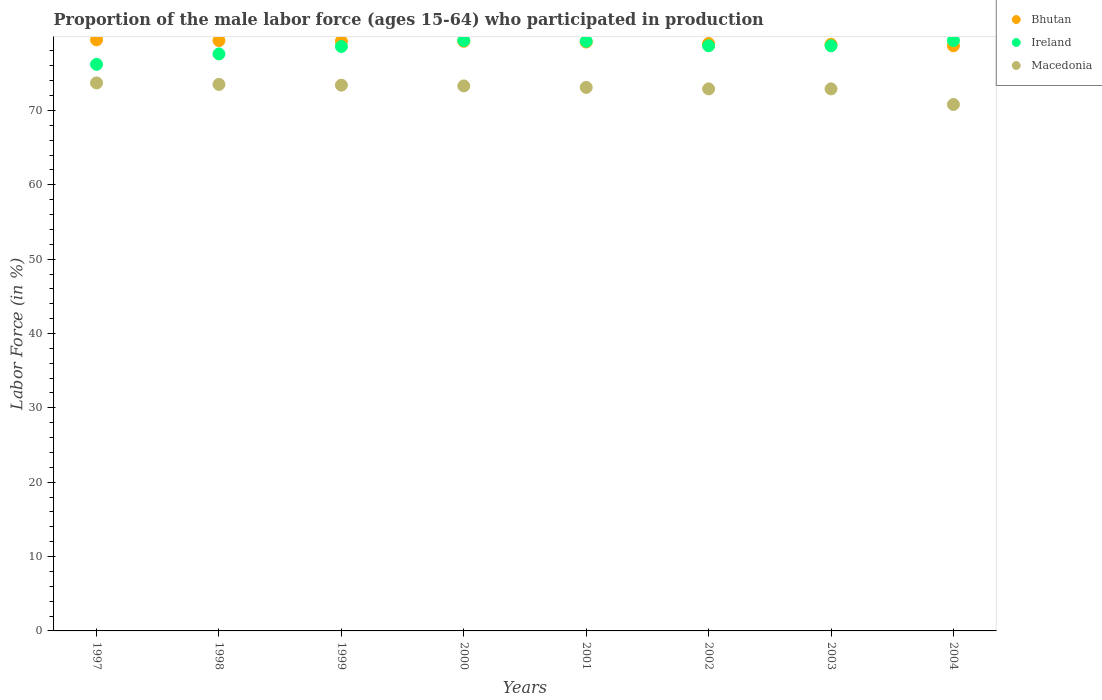How many different coloured dotlines are there?
Keep it short and to the point. 3. Is the number of dotlines equal to the number of legend labels?
Keep it short and to the point. Yes. What is the proportion of the male labor force who participated in production in Macedonia in 1999?
Give a very brief answer. 73.4. Across all years, what is the maximum proportion of the male labor force who participated in production in Ireland?
Ensure brevity in your answer.  79.4. Across all years, what is the minimum proportion of the male labor force who participated in production in Ireland?
Keep it short and to the point. 76.2. In which year was the proportion of the male labor force who participated in production in Bhutan maximum?
Your response must be concise. 1997. In which year was the proportion of the male labor force who participated in production in Bhutan minimum?
Your answer should be very brief. 2004. What is the total proportion of the male labor force who participated in production in Ireland in the graph?
Your answer should be very brief. 627.9. What is the difference between the proportion of the male labor force who participated in production in Macedonia in 1998 and that in 2001?
Your answer should be compact. 0.4. What is the difference between the proportion of the male labor force who participated in production in Macedonia in 2002 and the proportion of the male labor force who participated in production in Ireland in 1999?
Offer a terse response. -5.7. What is the average proportion of the male labor force who participated in production in Ireland per year?
Make the answer very short. 78.49. In the year 1997, what is the difference between the proportion of the male labor force who participated in production in Bhutan and proportion of the male labor force who participated in production in Macedonia?
Keep it short and to the point. 5.8. What is the ratio of the proportion of the male labor force who participated in production in Bhutan in 2000 to that in 2002?
Your response must be concise. 1. Is the proportion of the male labor force who participated in production in Ireland in 2001 less than that in 2003?
Your response must be concise. No. Is the difference between the proportion of the male labor force who participated in production in Bhutan in 1998 and 2000 greater than the difference between the proportion of the male labor force who participated in production in Macedonia in 1998 and 2000?
Provide a short and direct response. No. What is the difference between the highest and the second highest proportion of the male labor force who participated in production in Macedonia?
Provide a succinct answer. 0.2. What is the difference between the highest and the lowest proportion of the male labor force who participated in production in Ireland?
Your answer should be compact. 3.2. Is the sum of the proportion of the male labor force who participated in production in Bhutan in 1999 and 2004 greater than the maximum proportion of the male labor force who participated in production in Ireland across all years?
Offer a terse response. Yes. Is it the case that in every year, the sum of the proportion of the male labor force who participated in production in Macedonia and proportion of the male labor force who participated in production in Bhutan  is greater than the proportion of the male labor force who participated in production in Ireland?
Make the answer very short. Yes. Does the proportion of the male labor force who participated in production in Bhutan monotonically increase over the years?
Keep it short and to the point. No. Is the proportion of the male labor force who participated in production in Bhutan strictly greater than the proportion of the male labor force who participated in production in Ireland over the years?
Offer a very short reply. No. How many dotlines are there?
Provide a succinct answer. 3. How many years are there in the graph?
Make the answer very short. 8. What is the difference between two consecutive major ticks on the Y-axis?
Offer a terse response. 10. Does the graph contain grids?
Offer a terse response. No. Where does the legend appear in the graph?
Give a very brief answer. Top right. What is the title of the graph?
Make the answer very short. Proportion of the male labor force (ages 15-64) who participated in production. What is the Labor Force (in %) in Bhutan in 1997?
Your answer should be very brief. 79.5. What is the Labor Force (in %) of Ireland in 1997?
Your answer should be compact. 76.2. What is the Labor Force (in %) in Macedonia in 1997?
Keep it short and to the point. 73.7. What is the Labor Force (in %) of Bhutan in 1998?
Offer a terse response. 79.4. What is the Labor Force (in %) in Ireland in 1998?
Your response must be concise. 77.6. What is the Labor Force (in %) of Macedonia in 1998?
Ensure brevity in your answer.  73.5. What is the Labor Force (in %) in Bhutan in 1999?
Keep it short and to the point. 79.3. What is the Labor Force (in %) in Ireland in 1999?
Ensure brevity in your answer.  78.6. What is the Labor Force (in %) of Macedonia in 1999?
Give a very brief answer. 73.4. What is the Labor Force (in %) in Bhutan in 2000?
Keep it short and to the point. 79.3. What is the Labor Force (in %) of Ireland in 2000?
Provide a succinct answer. 79.4. What is the Labor Force (in %) in Macedonia in 2000?
Provide a short and direct response. 73.3. What is the Labor Force (in %) of Bhutan in 2001?
Provide a short and direct response. 79.2. What is the Labor Force (in %) in Ireland in 2001?
Give a very brief answer. 79.3. What is the Labor Force (in %) in Macedonia in 2001?
Provide a succinct answer. 73.1. What is the Labor Force (in %) of Bhutan in 2002?
Offer a very short reply. 79. What is the Labor Force (in %) of Ireland in 2002?
Your answer should be compact. 78.7. What is the Labor Force (in %) in Macedonia in 2002?
Your response must be concise. 72.9. What is the Labor Force (in %) in Bhutan in 2003?
Your response must be concise. 78.9. What is the Labor Force (in %) in Ireland in 2003?
Provide a short and direct response. 78.7. What is the Labor Force (in %) of Macedonia in 2003?
Provide a succinct answer. 72.9. What is the Labor Force (in %) in Bhutan in 2004?
Your answer should be compact. 78.7. What is the Labor Force (in %) in Ireland in 2004?
Provide a succinct answer. 79.4. What is the Labor Force (in %) in Macedonia in 2004?
Provide a short and direct response. 70.8. Across all years, what is the maximum Labor Force (in %) in Bhutan?
Your response must be concise. 79.5. Across all years, what is the maximum Labor Force (in %) of Ireland?
Your answer should be compact. 79.4. Across all years, what is the maximum Labor Force (in %) of Macedonia?
Keep it short and to the point. 73.7. Across all years, what is the minimum Labor Force (in %) in Bhutan?
Ensure brevity in your answer.  78.7. Across all years, what is the minimum Labor Force (in %) in Ireland?
Offer a very short reply. 76.2. Across all years, what is the minimum Labor Force (in %) of Macedonia?
Make the answer very short. 70.8. What is the total Labor Force (in %) in Bhutan in the graph?
Keep it short and to the point. 633.3. What is the total Labor Force (in %) of Ireland in the graph?
Provide a succinct answer. 627.9. What is the total Labor Force (in %) of Macedonia in the graph?
Provide a succinct answer. 583.6. What is the difference between the Labor Force (in %) in Macedonia in 1997 and that in 1998?
Ensure brevity in your answer.  0.2. What is the difference between the Labor Force (in %) in Bhutan in 1997 and that in 1999?
Keep it short and to the point. 0.2. What is the difference between the Labor Force (in %) in Ireland in 1997 and that in 1999?
Give a very brief answer. -2.4. What is the difference between the Labor Force (in %) in Macedonia in 1997 and that in 2000?
Your response must be concise. 0.4. What is the difference between the Labor Force (in %) in Ireland in 1997 and that in 2003?
Your response must be concise. -2.5. What is the difference between the Labor Force (in %) of Macedonia in 1997 and that in 2004?
Your response must be concise. 2.9. What is the difference between the Labor Force (in %) in Macedonia in 1998 and that in 1999?
Offer a terse response. 0.1. What is the difference between the Labor Force (in %) in Macedonia in 1998 and that in 2000?
Your answer should be compact. 0.2. What is the difference between the Labor Force (in %) of Ireland in 1998 and that in 2001?
Give a very brief answer. -1.7. What is the difference between the Labor Force (in %) in Ireland in 1998 and that in 2002?
Give a very brief answer. -1.1. What is the difference between the Labor Force (in %) of Ireland in 1998 and that in 2003?
Give a very brief answer. -1.1. What is the difference between the Labor Force (in %) of Macedonia in 1998 and that in 2003?
Make the answer very short. 0.6. What is the difference between the Labor Force (in %) in Bhutan in 1998 and that in 2004?
Your answer should be very brief. 0.7. What is the difference between the Labor Force (in %) in Ireland in 1998 and that in 2004?
Ensure brevity in your answer.  -1.8. What is the difference between the Labor Force (in %) in Ireland in 1999 and that in 2000?
Give a very brief answer. -0.8. What is the difference between the Labor Force (in %) of Macedonia in 1999 and that in 2000?
Make the answer very short. 0.1. What is the difference between the Labor Force (in %) in Bhutan in 1999 and that in 2001?
Ensure brevity in your answer.  0.1. What is the difference between the Labor Force (in %) of Ireland in 1999 and that in 2001?
Give a very brief answer. -0.7. What is the difference between the Labor Force (in %) in Macedonia in 1999 and that in 2001?
Your response must be concise. 0.3. What is the difference between the Labor Force (in %) of Ireland in 1999 and that in 2002?
Offer a very short reply. -0.1. What is the difference between the Labor Force (in %) in Macedonia in 1999 and that in 2002?
Offer a terse response. 0.5. What is the difference between the Labor Force (in %) of Ireland in 1999 and that in 2003?
Offer a very short reply. -0.1. What is the difference between the Labor Force (in %) of Macedonia in 1999 and that in 2003?
Make the answer very short. 0.5. What is the difference between the Labor Force (in %) of Macedonia in 1999 and that in 2004?
Make the answer very short. 2.6. What is the difference between the Labor Force (in %) in Macedonia in 2000 and that in 2001?
Make the answer very short. 0.2. What is the difference between the Labor Force (in %) of Bhutan in 2000 and that in 2002?
Offer a very short reply. 0.3. What is the difference between the Labor Force (in %) in Ireland in 2000 and that in 2002?
Ensure brevity in your answer.  0.7. What is the difference between the Labor Force (in %) in Macedonia in 2000 and that in 2002?
Offer a terse response. 0.4. What is the difference between the Labor Force (in %) of Bhutan in 2000 and that in 2003?
Ensure brevity in your answer.  0.4. What is the difference between the Labor Force (in %) in Bhutan in 2000 and that in 2004?
Your response must be concise. 0.6. What is the difference between the Labor Force (in %) in Ireland in 2000 and that in 2004?
Your answer should be compact. 0. What is the difference between the Labor Force (in %) of Macedonia in 2000 and that in 2004?
Keep it short and to the point. 2.5. What is the difference between the Labor Force (in %) of Bhutan in 2001 and that in 2002?
Ensure brevity in your answer.  0.2. What is the difference between the Labor Force (in %) of Macedonia in 2001 and that in 2003?
Offer a very short reply. 0.2. What is the difference between the Labor Force (in %) in Ireland in 2001 and that in 2004?
Make the answer very short. -0.1. What is the difference between the Labor Force (in %) of Macedonia in 2001 and that in 2004?
Keep it short and to the point. 2.3. What is the difference between the Labor Force (in %) of Bhutan in 2002 and that in 2003?
Offer a very short reply. 0.1. What is the difference between the Labor Force (in %) of Ireland in 2002 and that in 2003?
Provide a short and direct response. 0. What is the difference between the Labor Force (in %) in Bhutan in 2002 and that in 2004?
Your answer should be compact. 0.3. What is the difference between the Labor Force (in %) in Macedonia in 2002 and that in 2004?
Keep it short and to the point. 2.1. What is the difference between the Labor Force (in %) in Ireland in 2003 and that in 2004?
Keep it short and to the point. -0.7. What is the difference between the Labor Force (in %) of Bhutan in 1997 and the Labor Force (in %) of Macedonia in 1998?
Your response must be concise. 6. What is the difference between the Labor Force (in %) in Bhutan in 1997 and the Labor Force (in %) in Ireland in 1999?
Offer a terse response. 0.9. What is the difference between the Labor Force (in %) in Bhutan in 1997 and the Labor Force (in %) in Macedonia in 1999?
Your response must be concise. 6.1. What is the difference between the Labor Force (in %) of Ireland in 1997 and the Labor Force (in %) of Macedonia in 1999?
Provide a succinct answer. 2.8. What is the difference between the Labor Force (in %) of Bhutan in 1997 and the Labor Force (in %) of Ireland in 2000?
Keep it short and to the point. 0.1. What is the difference between the Labor Force (in %) in Bhutan in 1997 and the Labor Force (in %) in Macedonia in 2000?
Offer a terse response. 6.2. What is the difference between the Labor Force (in %) in Ireland in 1997 and the Labor Force (in %) in Macedonia in 2000?
Offer a very short reply. 2.9. What is the difference between the Labor Force (in %) in Bhutan in 1997 and the Labor Force (in %) in Ireland in 2001?
Keep it short and to the point. 0.2. What is the difference between the Labor Force (in %) in Bhutan in 1997 and the Labor Force (in %) in Ireland in 2002?
Your answer should be compact. 0.8. What is the difference between the Labor Force (in %) in Bhutan in 1997 and the Labor Force (in %) in Macedonia in 2002?
Offer a very short reply. 6.6. What is the difference between the Labor Force (in %) of Bhutan in 1997 and the Labor Force (in %) of Ireland in 2003?
Offer a very short reply. 0.8. What is the difference between the Labor Force (in %) of Bhutan in 1997 and the Labor Force (in %) of Macedonia in 2003?
Offer a very short reply. 6.6. What is the difference between the Labor Force (in %) in Bhutan in 1997 and the Labor Force (in %) in Ireland in 2004?
Your answer should be compact. 0.1. What is the difference between the Labor Force (in %) of Ireland in 1997 and the Labor Force (in %) of Macedonia in 2004?
Ensure brevity in your answer.  5.4. What is the difference between the Labor Force (in %) of Bhutan in 1998 and the Labor Force (in %) of Ireland in 2003?
Keep it short and to the point. 0.7. What is the difference between the Labor Force (in %) in Bhutan in 1998 and the Labor Force (in %) in Macedonia in 2003?
Your answer should be very brief. 6.5. What is the difference between the Labor Force (in %) of Ireland in 1998 and the Labor Force (in %) of Macedonia in 2003?
Provide a short and direct response. 4.7. What is the difference between the Labor Force (in %) of Bhutan in 1998 and the Labor Force (in %) of Ireland in 2004?
Provide a short and direct response. 0. What is the difference between the Labor Force (in %) in Bhutan in 1998 and the Labor Force (in %) in Macedonia in 2004?
Ensure brevity in your answer.  8.6. What is the difference between the Labor Force (in %) in Bhutan in 1999 and the Labor Force (in %) in Ireland in 2000?
Keep it short and to the point. -0.1. What is the difference between the Labor Force (in %) in Bhutan in 1999 and the Labor Force (in %) in Macedonia in 2000?
Give a very brief answer. 6. What is the difference between the Labor Force (in %) in Bhutan in 1999 and the Labor Force (in %) in Ireland in 2002?
Offer a very short reply. 0.6. What is the difference between the Labor Force (in %) in Ireland in 1999 and the Labor Force (in %) in Macedonia in 2002?
Make the answer very short. 5.7. What is the difference between the Labor Force (in %) of Bhutan in 1999 and the Labor Force (in %) of Ireland in 2003?
Give a very brief answer. 0.6. What is the difference between the Labor Force (in %) of Bhutan in 1999 and the Labor Force (in %) of Macedonia in 2003?
Ensure brevity in your answer.  6.4. What is the difference between the Labor Force (in %) in Bhutan in 2000 and the Labor Force (in %) in Ireland in 2001?
Provide a short and direct response. 0. What is the difference between the Labor Force (in %) of Bhutan in 2000 and the Labor Force (in %) of Macedonia in 2002?
Keep it short and to the point. 6.4. What is the difference between the Labor Force (in %) of Ireland in 2000 and the Labor Force (in %) of Macedonia in 2002?
Your answer should be compact. 6.5. What is the difference between the Labor Force (in %) of Bhutan in 2000 and the Labor Force (in %) of Macedonia in 2003?
Offer a terse response. 6.4. What is the difference between the Labor Force (in %) in Ireland in 2000 and the Labor Force (in %) in Macedonia in 2004?
Your answer should be compact. 8.6. What is the difference between the Labor Force (in %) in Bhutan in 2001 and the Labor Force (in %) in Ireland in 2002?
Your answer should be very brief. 0.5. What is the difference between the Labor Force (in %) in Ireland in 2001 and the Labor Force (in %) in Macedonia in 2002?
Offer a very short reply. 6.4. What is the difference between the Labor Force (in %) of Bhutan in 2001 and the Labor Force (in %) of Macedonia in 2003?
Provide a short and direct response. 6.3. What is the difference between the Labor Force (in %) in Ireland in 2002 and the Labor Force (in %) in Macedonia in 2003?
Your answer should be very brief. 5.8. What is the difference between the Labor Force (in %) in Ireland in 2003 and the Labor Force (in %) in Macedonia in 2004?
Your response must be concise. 7.9. What is the average Labor Force (in %) of Bhutan per year?
Give a very brief answer. 79.16. What is the average Labor Force (in %) of Ireland per year?
Ensure brevity in your answer.  78.49. What is the average Labor Force (in %) in Macedonia per year?
Keep it short and to the point. 72.95. In the year 1997, what is the difference between the Labor Force (in %) in Bhutan and Labor Force (in %) in Macedonia?
Your answer should be compact. 5.8. In the year 1997, what is the difference between the Labor Force (in %) in Ireland and Labor Force (in %) in Macedonia?
Provide a short and direct response. 2.5. In the year 1998, what is the difference between the Labor Force (in %) in Bhutan and Labor Force (in %) in Ireland?
Keep it short and to the point. 1.8. In the year 2000, what is the difference between the Labor Force (in %) in Bhutan and Labor Force (in %) in Ireland?
Keep it short and to the point. -0.1. In the year 2000, what is the difference between the Labor Force (in %) of Bhutan and Labor Force (in %) of Macedonia?
Offer a terse response. 6. In the year 2001, what is the difference between the Labor Force (in %) in Bhutan and Labor Force (in %) in Macedonia?
Give a very brief answer. 6.1. In the year 2003, what is the difference between the Labor Force (in %) of Bhutan and Labor Force (in %) of Ireland?
Offer a terse response. 0.2. In the year 2004, what is the difference between the Labor Force (in %) in Bhutan and Labor Force (in %) in Ireland?
Provide a short and direct response. -0.7. In the year 2004, what is the difference between the Labor Force (in %) in Ireland and Labor Force (in %) in Macedonia?
Make the answer very short. 8.6. What is the ratio of the Labor Force (in %) of Bhutan in 1997 to that in 1998?
Keep it short and to the point. 1. What is the ratio of the Labor Force (in %) in Ireland in 1997 to that in 1998?
Your answer should be very brief. 0.98. What is the ratio of the Labor Force (in %) in Bhutan in 1997 to that in 1999?
Provide a short and direct response. 1. What is the ratio of the Labor Force (in %) of Ireland in 1997 to that in 1999?
Provide a succinct answer. 0.97. What is the ratio of the Labor Force (in %) in Bhutan in 1997 to that in 2000?
Your answer should be very brief. 1. What is the ratio of the Labor Force (in %) of Ireland in 1997 to that in 2000?
Provide a short and direct response. 0.96. What is the ratio of the Labor Force (in %) in Macedonia in 1997 to that in 2000?
Provide a succinct answer. 1.01. What is the ratio of the Labor Force (in %) in Bhutan in 1997 to that in 2001?
Ensure brevity in your answer.  1. What is the ratio of the Labor Force (in %) in Ireland in 1997 to that in 2001?
Your answer should be very brief. 0.96. What is the ratio of the Labor Force (in %) of Macedonia in 1997 to that in 2001?
Your response must be concise. 1.01. What is the ratio of the Labor Force (in %) of Bhutan in 1997 to that in 2002?
Keep it short and to the point. 1.01. What is the ratio of the Labor Force (in %) of Ireland in 1997 to that in 2002?
Offer a terse response. 0.97. What is the ratio of the Labor Force (in %) in Macedonia in 1997 to that in 2002?
Provide a short and direct response. 1.01. What is the ratio of the Labor Force (in %) of Bhutan in 1997 to that in 2003?
Make the answer very short. 1.01. What is the ratio of the Labor Force (in %) of Ireland in 1997 to that in 2003?
Keep it short and to the point. 0.97. What is the ratio of the Labor Force (in %) of Bhutan in 1997 to that in 2004?
Offer a very short reply. 1.01. What is the ratio of the Labor Force (in %) in Ireland in 1997 to that in 2004?
Your answer should be compact. 0.96. What is the ratio of the Labor Force (in %) in Macedonia in 1997 to that in 2004?
Your response must be concise. 1.04. What is the ratio of the Labor Force (in %) of Bhutan in 1998 to that in 1999?
Make the answer very short. 1. What is the ratio of the Labor Force (in %) in Ireland in 1998 to that in 1999?
Keep it short and to the point. 0.99. What is the ratio of the Labor Force (in %) in Bhutan in 1998 to that in 2000?
Give a very brief answer. 1. What is the ratio of the Labor Force (in %) in Ireland in 1998 to that in 2000?
Your response must be concise. 0.98. What is the ratio of the Labor Force (in %) in Macedonia in 1998 to that in 2000?
Provide a short and direct response. 1. What is the ratio of the Labor Force (in %) in Ireland in 1998 to that in 2001?
Your answer should be very brief. 0.98. What is the ratio of the Labor Force (in %) of Bhutan in 1998 to that in 2002?
Provide a succinct answer. 1.01. What is the ratio of the Labor Force (in %) of Macedonia in 1998 to that in 2002?
Ensure brevity in your answer.  1.01. What is the ratio of the Labor Force (in %) in Macedonia in 1998 to that in 2003?
Ensure brevity in your answer.  1.01. What is the ratio of the Labor Force (in %) of Bhutan in 1998 to that in 2004?
Keep it short and to the point. 1.01. What is the ratio of the Labor Force (in %) of Ireland in 1998 to that in 2004?
Keep it short and to the point. 0.98. What is the ratio of the Labor Force (in %) of Macedonia in 1998 to that in 2004?
Ensure brevity in your answer.  1.04. What is the ratio of the Labor Force (in %) of Bhutan in 1999 to that in 2000?
Your response must be concise. 1. What is the ratio of the Labor Force (in %) in Bhutan in 1999 to that in 2001?
Provide a short and direct response. 1. What is the ratio of the Labor Force (in %) in Macedonia in 1999 to that in 2001?
Give a very brief answer. 1. What is the ratio of the Labor Force (in %) in Bhutan in 1999 to that in 2002?
Keep it short and to the point. 1. What is the ratio of the Labor Force (in %) in Ireland in 1999 to that in 2002?
Give a very brief answer. 1. What is the ratio of the Labor Force (in %) in Bhutan in 1999 to that in 2003?
Keep it short and to the point. 1.01. What is the ratio of the Labor Force (in %) of Ireland in 1999 to that in 2003?
Offer a very short reply. 1. What is the ratio of the Labor Force (in %) of Bhutan in 1999 to that in 2004?
Your response must be concise. 1.01. What is the ratio of the Labor Force (in %) in Ireland in 1999 to that in 2004?
Make the answer very short. 0.99. What is the ratio of the Labor Force (in %) in Macedonia in 1999 to that in 2004?
Offer a very short reply. 1.04. What is the ratio of the Labor Force (in %) in Ireland in 2000 to that in 2001?
Make the answer very short. 1. What is the ratio of the Labor Force (in %) of Bhutan in 2000 to that in 2002?
Offer a terse response. 1. What is the ratio of the Labor Force (in %) of Ireland in 2000 to that in 2002?
Make the answer very short. 1.01. What is the ratio of the Labor Force (in %) of Bhutan in 2000 to that in 2003?
Provide a succinct answer. 1.01. What is the ratio of the Labor Force (in %) in Ireland in 2000 to that in 2003?
Offer a very short reply. 1.01. What is the ratio of the Labor Force (in %) of Bhutan in 2000 to that in 2004?
Keep it short and to the point. 1.01. What is the ratio of the Labor Force (in %) in Macedonia in 2000 to that in 2004?
Your response must be concise. 1.04. What is the ratio of the Labor Force (in %) in Bhutan in 2001 to that in 2002?
Your response must be concise. 1. What is the ratio of the Labor Force (in %) of Ireland in 2001 to that in 2002?
Provide a short and direct response. 1.01. What is the ratio of the Labor Force (in %) in Macedonia in 2001 to that in 2002?
Keep it short and to the point. 1. What is the ratio of the Labor Force (in %) of Ireland in 2001 to that in 2003?
Ensure brevity in your answer.  1.01. What is the ratio of the Labor Force (in %) in Macedonia in 2001 to that in 2003?
Provide a succinct answer. 1. What is the ratio of the Labor Force (in %) of Bhutan in 2001 to that in 2004?
Keep it short and to the point. 1.01. What is the ratio of the Labor Force (in %) of Macedonia in 2001 to that in 2004?
Your answer should be compact. 1.03. What is the ratio of the Labor Force (in %) in Bhutan in 2002 to that in 2003?
Give a very brief answer. 1. What is the ratio of the Labor Force (in %) of Ireland in 2002 to that in 2004?
Provide a short and direct response. 0.99. What is the ratio of the Labor Force (in %) in Macedonia in 2002 to that in 2004?
Offer a terse response. 1.03. What is the ratio of the Labor Force (in %) of Ireland in 2003 to that in 2004?
Ensure brevity in your answer.  0.99. What is the ratio of the Labor Force (in %) in Macedonia in 2003 to that in 2004?
Your answer should be very brief. 1.03. What is the difference between the highest and the lowest Labor Force (in %) in Bhutan?
Keep it short and to the point. 0.8. What is the difference between the highest and the lowest Labor Force (in %) in Ireland?
Offer a very short reply. 3.2. 